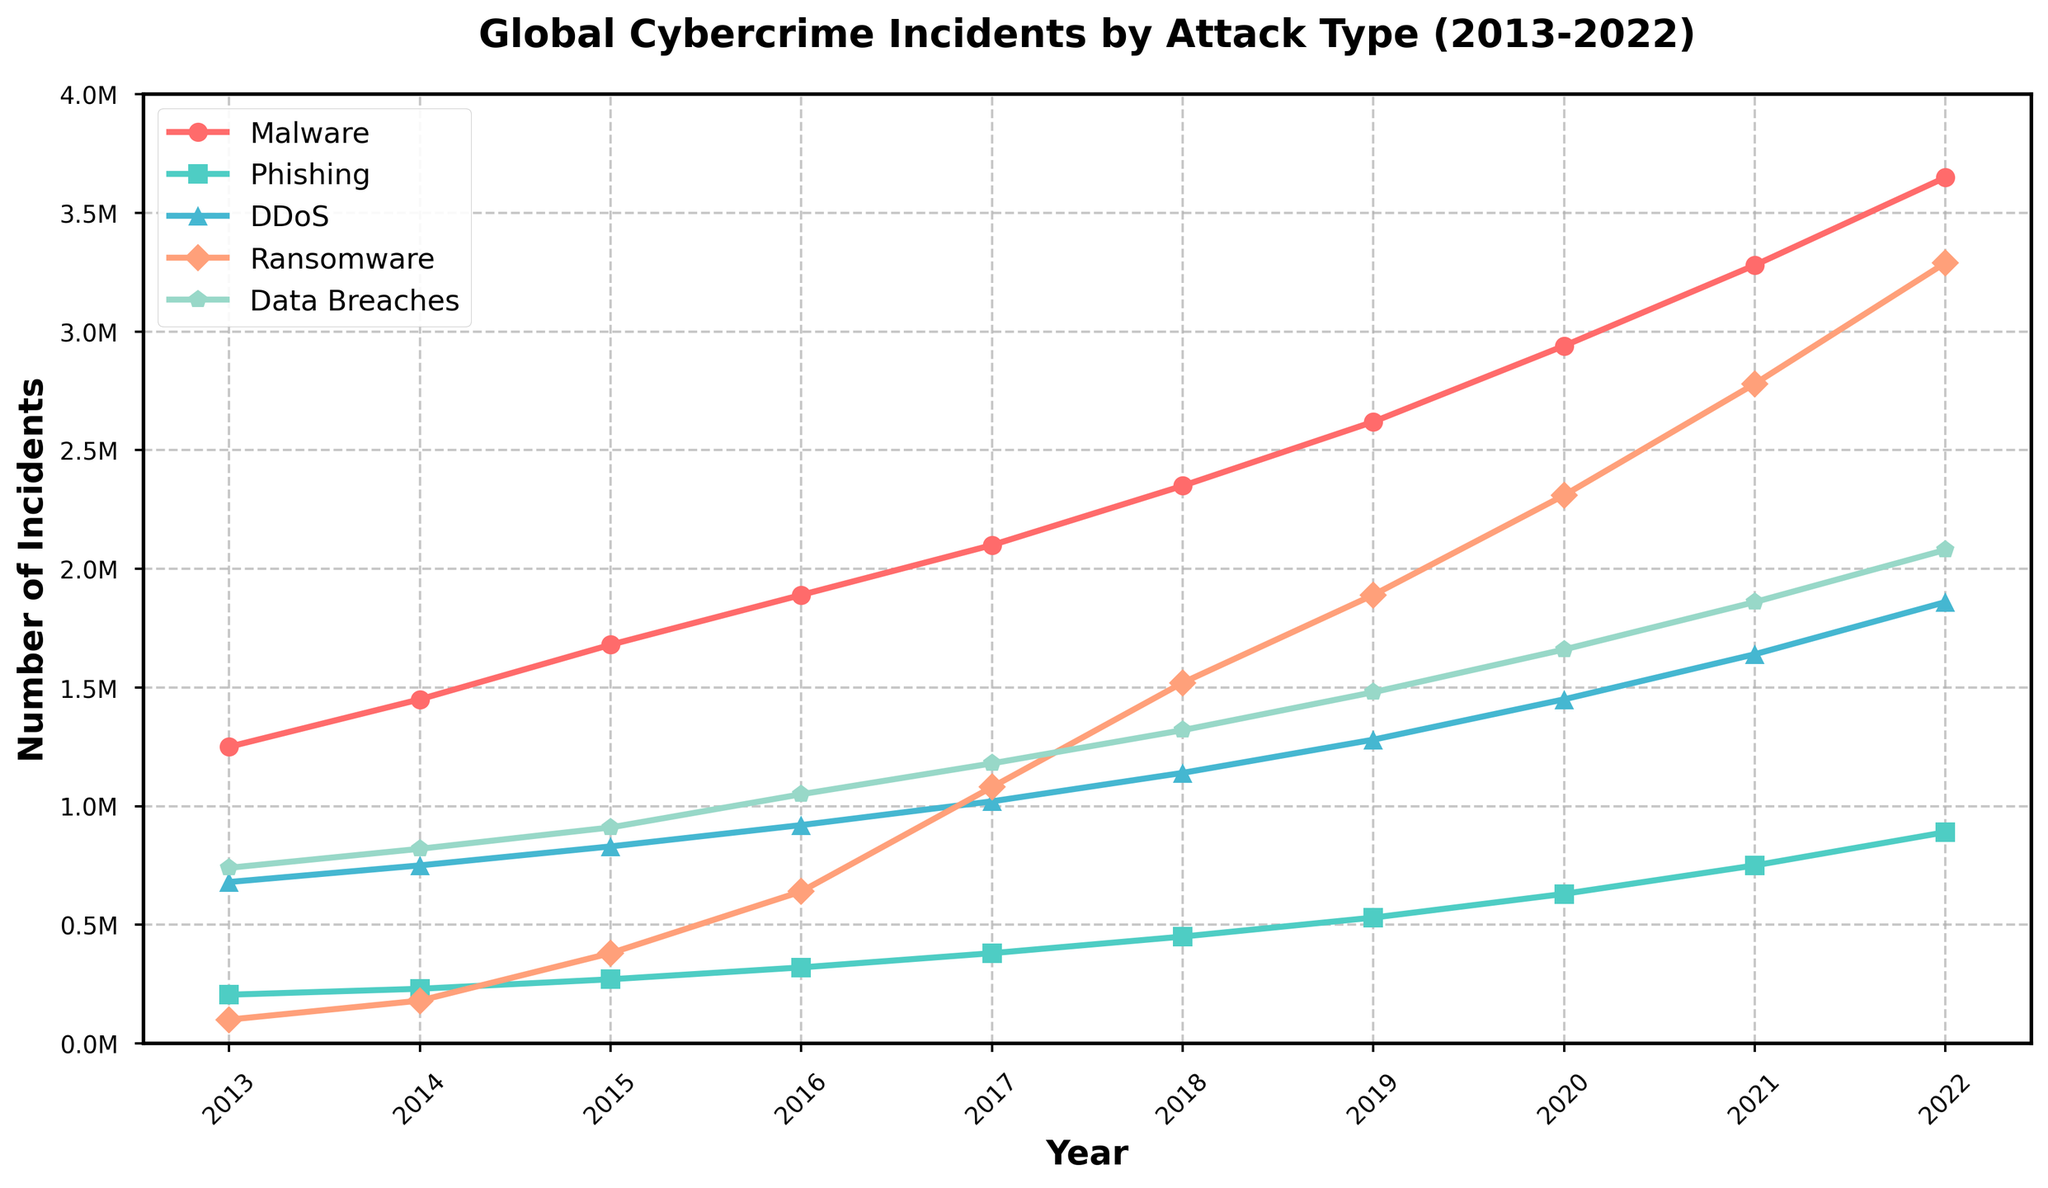What is the overall trend for Malware incidents from 2013 to 2022? To determine the overall trend, observe the plot line for Malware over the range of years. It consistently increases without any dips, indicating a steady rise in Malware incidents over the decade.
Answer: Increasing Which year experienced the highest number of Phishing incidents? By looking at the graph, the peak of the Phishing line (green) is in the year 2022, where the value reaches its maximum.
Answer: 2022 How many more Data Breaches occurred in 2022 compared to 2016? Look at the number of Data Breaches in 2022 and 2016. In 2022, there were 2,080,000 incidents, and in 2016, there were 1,050,000 incidents. Subtract the number of incidents in 2016 from 2022 (2,080,000 - 1,050,000).
Answer: 1,030,000 Which type of attack had the smallest increase in incidents between 2013 and 2022? Calculate the difference in the number of incidents between 2022 and 2013 for each type of attack. Phishing had the smallest increase (890,000 - 205,000 = 685,000), smaller than the other types.
Answer: Phishing Compare the incident trend between Ransomware and DDoS in 2018. Which type had more incidents, and by how much? In 2018, Ransomware incidents are 1,520,000 and DDoS incidents are 1,140,000. Subtract the number of DDoS incidents from Ransomware incidents (1,520,000 - 1,140,000).
Answer: Ransomware by 380,000 What can be inferred about the trend in Data Breaches from 2013 to 2022? Observe the graph line for Data Breaches, which consistently increases each year, indicating a significant rising trend in Data Breaches over the decade.
Answer: Increasing How do the number of Malware incidents in 2014 and 2015 compare? Check the points on the graph for Malware in 2014 and 2015. In 2014, the number is 1,450,000, and in 2015, it is 1,680,000.
Answer: Higher in 2015 